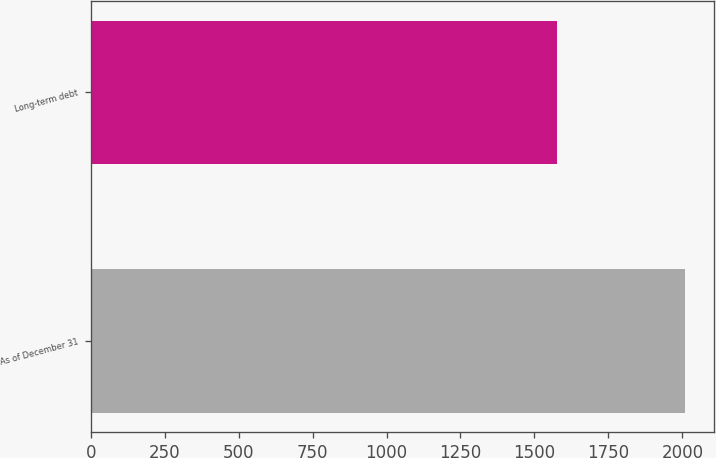Convert chart. <chart><loc_0><loc_0><loc_500><loc_500><bar_chart><fcel>As of December 31<fcel>Long-term debt<nl><fcel>2008<fcel>1576<nl></chart> 